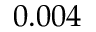<formula> <loc_0><loc_0><loc_500><loc_500>0 . 0 0 4</formula> 